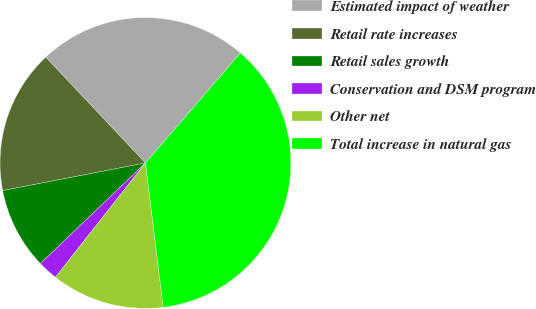<chart> <loc_0><loc_0><loc_500><loc_500><pie_chart><fcel>Estimated impact of weather<fcel>Retail rate increases<fcel>Retail sales growth<fcel>Conservation and DSM program<fcel>Other net<fcel>Total increase in natural gas<nl><fcel>23.36%<fcel>16.02%<fcel>9.12%<fcel>2.22%<fcel>12.57%<fcel>36.71%<nl></chart> 